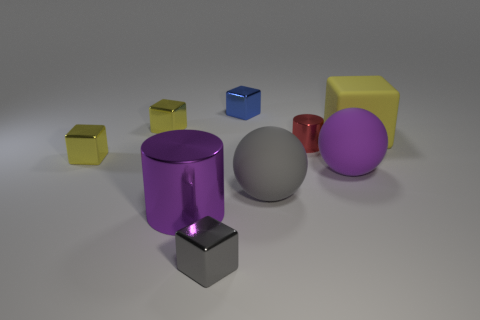Are the purple cylinder and the purple sphere made of the same material?
Give a very brief answer. No. How many blue objects are large matte spheres or large metal spheres?
Provide a short and direct response. 0. How many large purple objects are the same shape as the big yellow rubber thing?
Offer a terse response. 0. What material is the large gray ball?
Your response must be concise. Rubber. Are there an equal number of tiny blue blocks that are to the left of the blue shiny cube and tiny cubes?
Ensure brevity in your answer.  No. What shape is the gray metallic object that is the same size as the red metallic cylinder?
Keep it short and to the point. Cube. There is a tiny thing that is on the right side of the gray matte sphere; is there a large yellow cube in front of it?
Your answer should be very brief. No. How many small things are red shiny cylinders or yellow blocks?
Offer a terse response. 3. Is there a red matte ball that has the same size as the purple matte object?
Provide a succinct answer. No. How many metal objects are either gray objects or yellow cubes?
Keep it short and to the point. 3. 